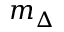Convert formula to latex. <formula><loc_0><loc_0><loc_500><loc_500>m _ { \Delta }</formula> 